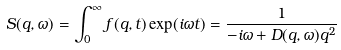<formula> <loc_0><loc_0><loc_500><loc_500>S ( q , \omega ) = \int _ { 0 } ^ { \infty } f ( q , t ) \exp ( i \omega t ) = \frac { 1 } { - i \omega + D ( q , \omega ) q ^ { 2 } }</formula> 